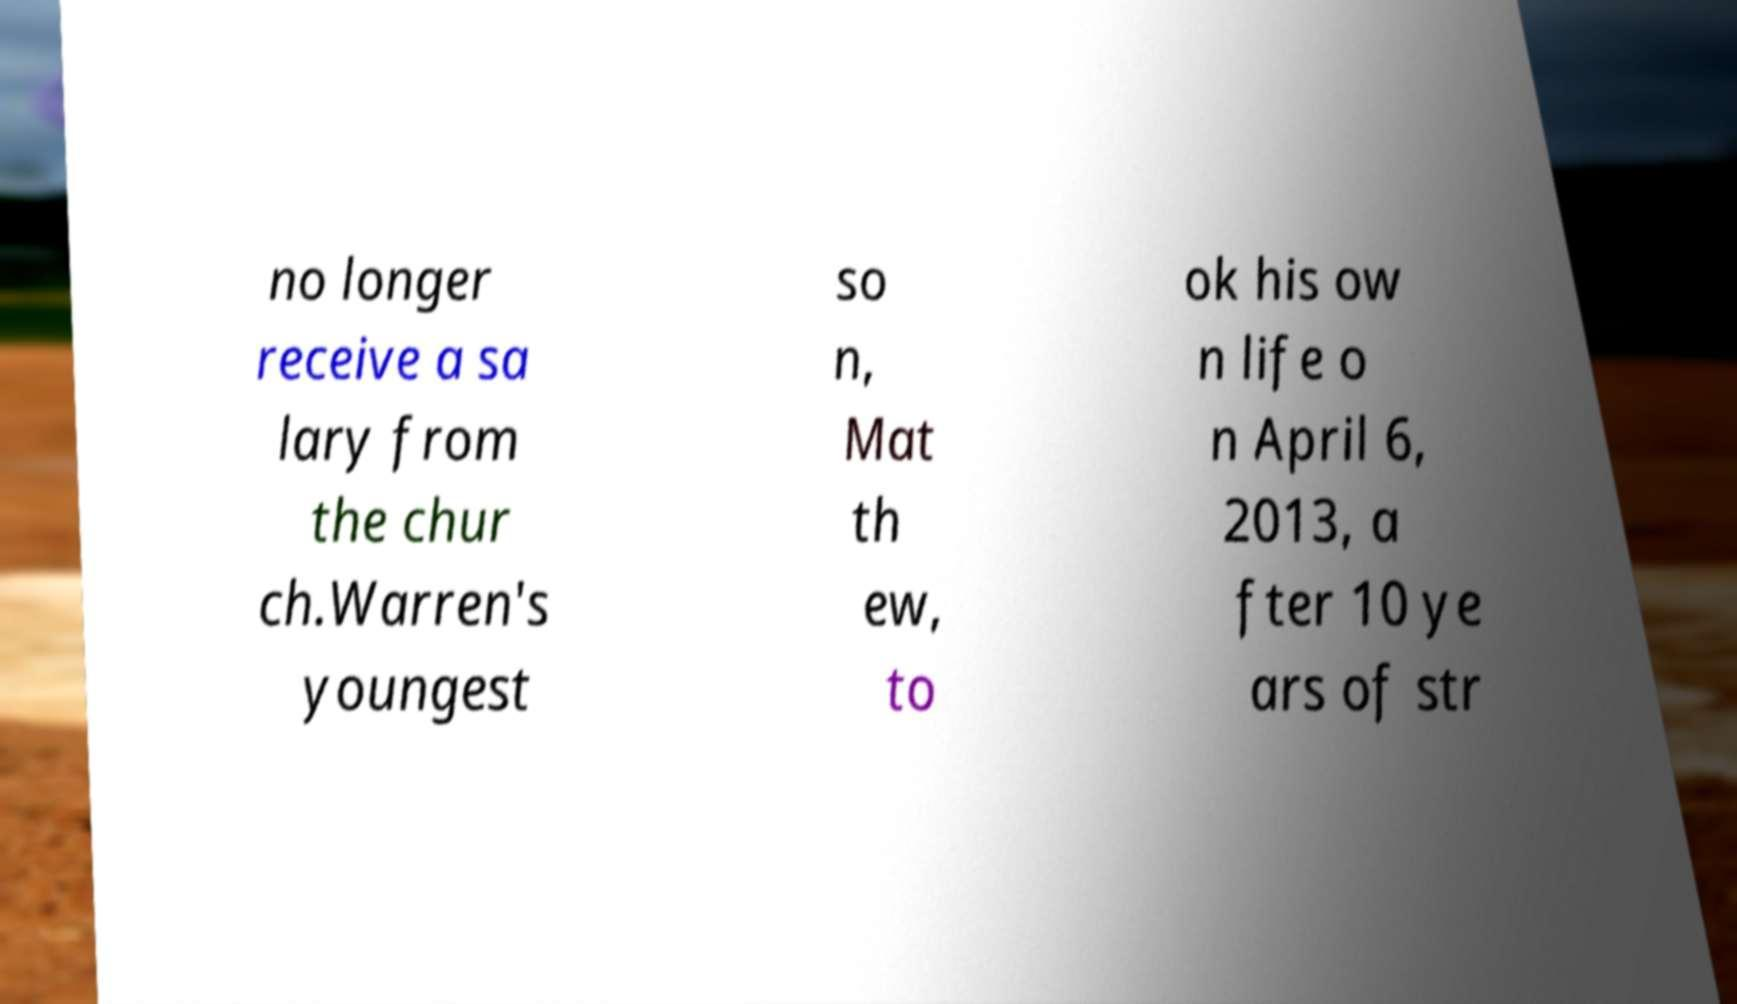Can you read and provide the text displayed in the image?This photo seems to have some interesting text. Can you extract and type it out for me? no longer receive a sa lary from the chur ch.Warren's youngest so n, Mat th ew, to ok his ow n life o n April 6, 2013, a fter 10 ye ars of str 